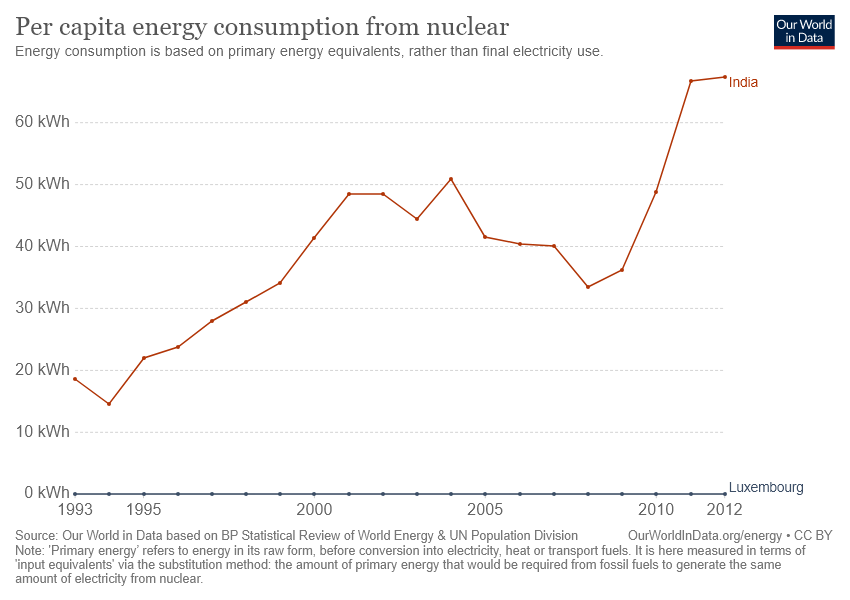Identify some key points in this picture. The graph shows two countries. The difference between the two countries was at its greatest in the years 2010 and 2011. 